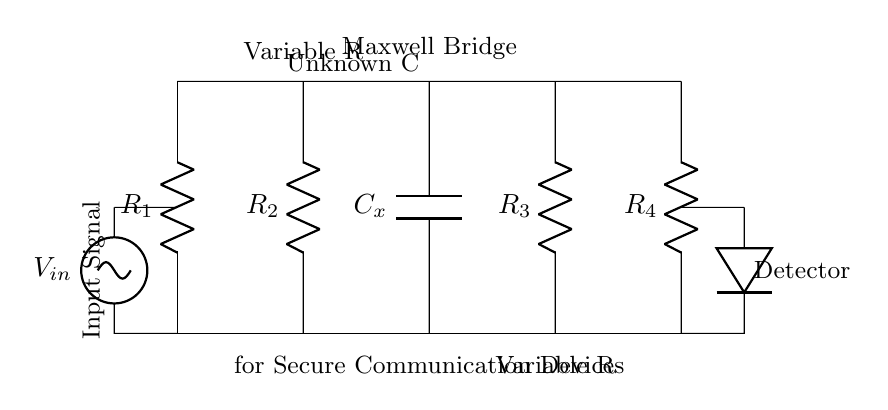What is the type of bridge shown in the circuit? The diagram represents a Maxwell Bridge, which is used for measuring unknown capacitances. This is indicated by the label in the circuit diagram.
Answer: Maxwell Bridge What are the components used in the circuit? The components include resistors and a capacitor, specifically four resistors labeled R1, R2, R3, R4 and an unknown capacitor labeled Cx. This can be identified by the component labels present in the diagram.
Answer: Resistors and Capacitor What is the purpose of Cx in the circuit? Cx is the unknown capacitance that the Maxwell Bridge is designed to measure. The label indicates that it is an essential part of the bridge, contributing to the balance condition.
Answer: Measure unknown capacitance How many resistors are present in the Maxwell Bridge? The diagram shows a total of four resistors connected in the circuit. Each resistor is clearly labeled from R1 to R4, making it easy to count them.
Answer: Four What is the function of the input signal in the circuit? The input signal is applied to the bridge circuit to initiate the analysis of the capacitance, allowing the detector to measure deviations and balance the bridge accordingly. This can be inferred from its position in the diagram.
Answer: Initiate capacitance analysis How does the balance condition work in a Maxwell Bridge? In a Maxwell Bridge, the balance condition is achieved when the voltage across the detector is zero, meaning the ratio of resistances and capacitance is equal. The bridge circuit is designed to vary resistors to reach this equilibrium. This requires understanding how the ratios of components affect the voltage across the detector, which is fundamental in bridge circuits.
Answer: Voltage across detector is zero What role does the variable resistance play in this circuit? The variable resistance allows for precise adjustments to attain the balance condition in the bridge. By changing the resistance values, the user can effectively manipulate the circuit to reach equilibrium, aiding the accurate measurement of the unknown capacitance. This is a characteristic feature of bridge circuits, as they rely on adjustable elements for calibration.
Answer: Achieve balance condition 